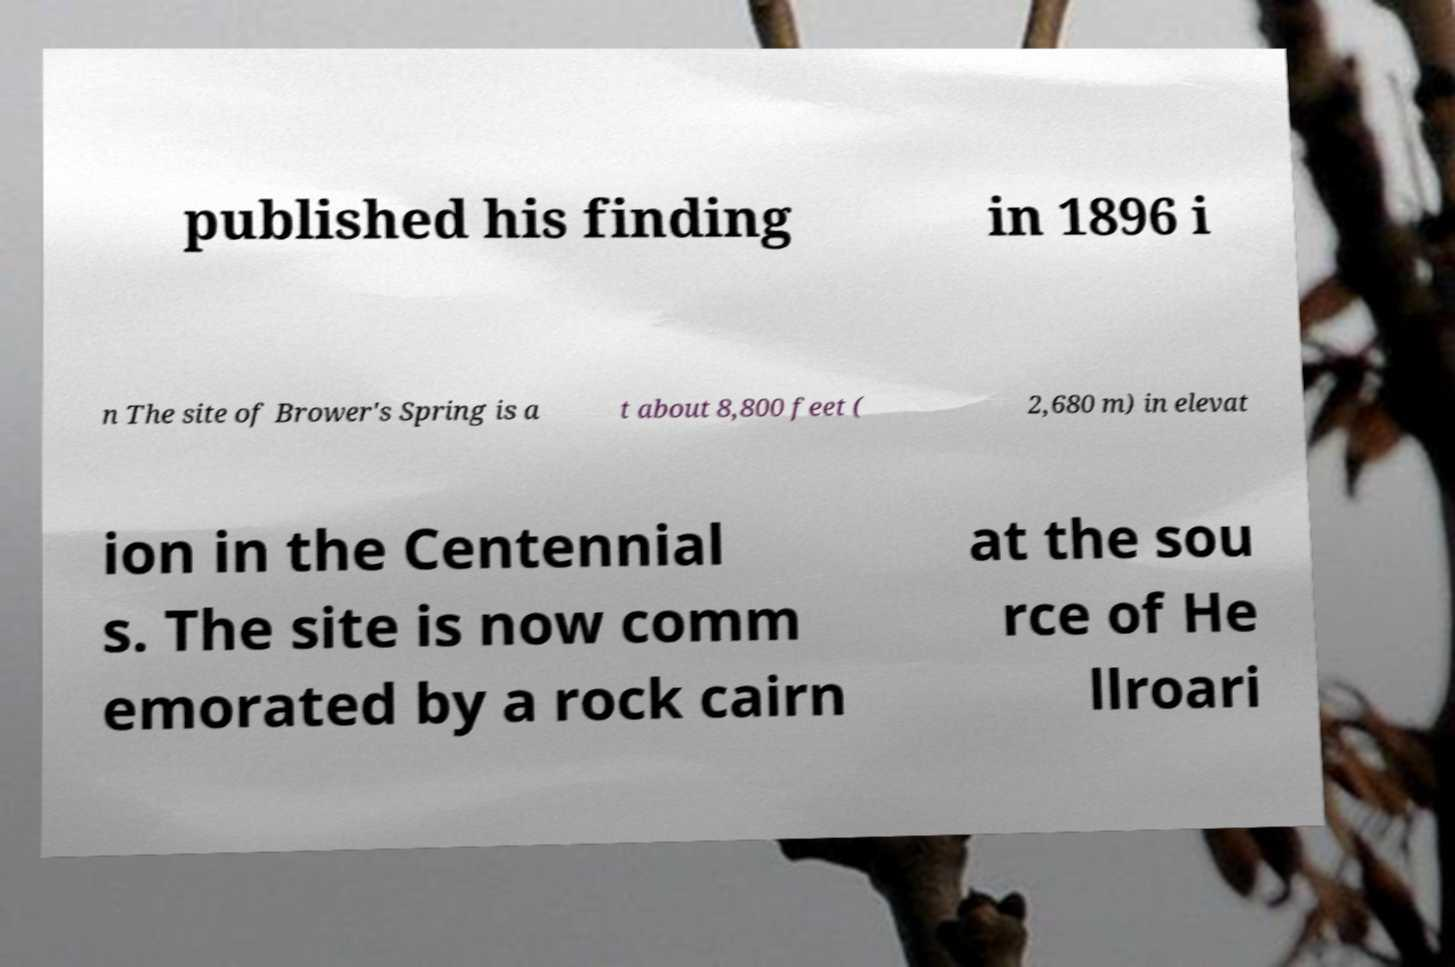For documentation purposes, I need the text within this image transcribed. Could you provide that? published his finding in 1896 i n The site of Brower's Spring is a t about 8,800 feet ( 2,680 m) in elevat ion in the Centennial s. The site is now comm emorated by a rock cairn at the sou rce of He llroari 